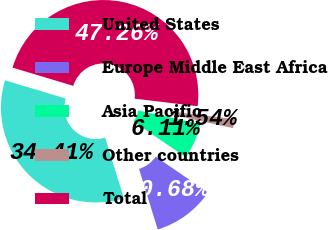Convert chart. <chart><loc_0><loc_0><loc_500><loc_500><pie_chart><fcel>United States<fcel>Europe Middle East Africa<fcel>Asia Pacific<fcel>Other countries<fcel>Total<nl><fcel>34.41%<fcel>10.68%<fcel>6.11%<fcel>1.54%<fcel>47.26%<nl></chart> 